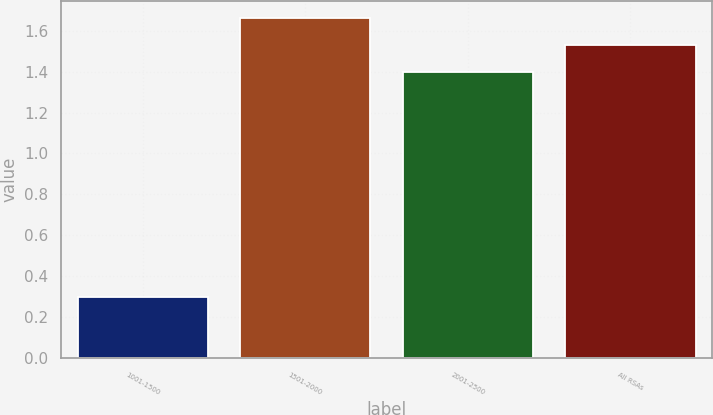Convert chart. <chart><loc_0><loc_0><loc_500><loc_500><bar_chart><fcel>1001-1500<fcel>1501-2000<fcel>2001-2500<fcel>All RSAs<nl><fcel>0.3<fcel>1.66<fcel>1.4<fcel>1.53<nl></chart> 